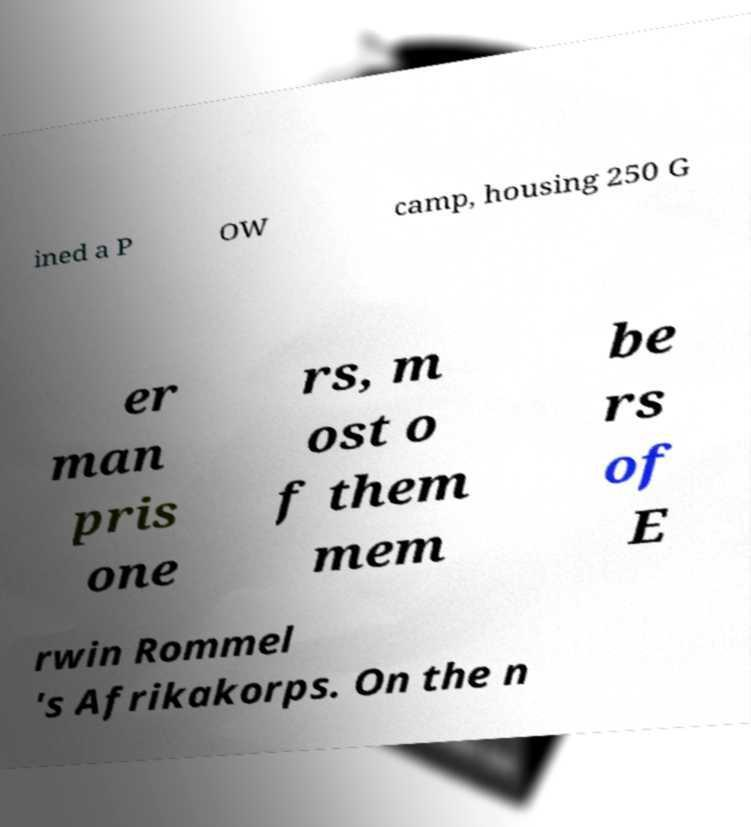Can you accurately transcribe the text from the provided image for me? ined a P OW camp, housing 250 G er man pris one rs, m ost o f them mem be rs of E rwin Rommel 's Afrikakorps. On the n 